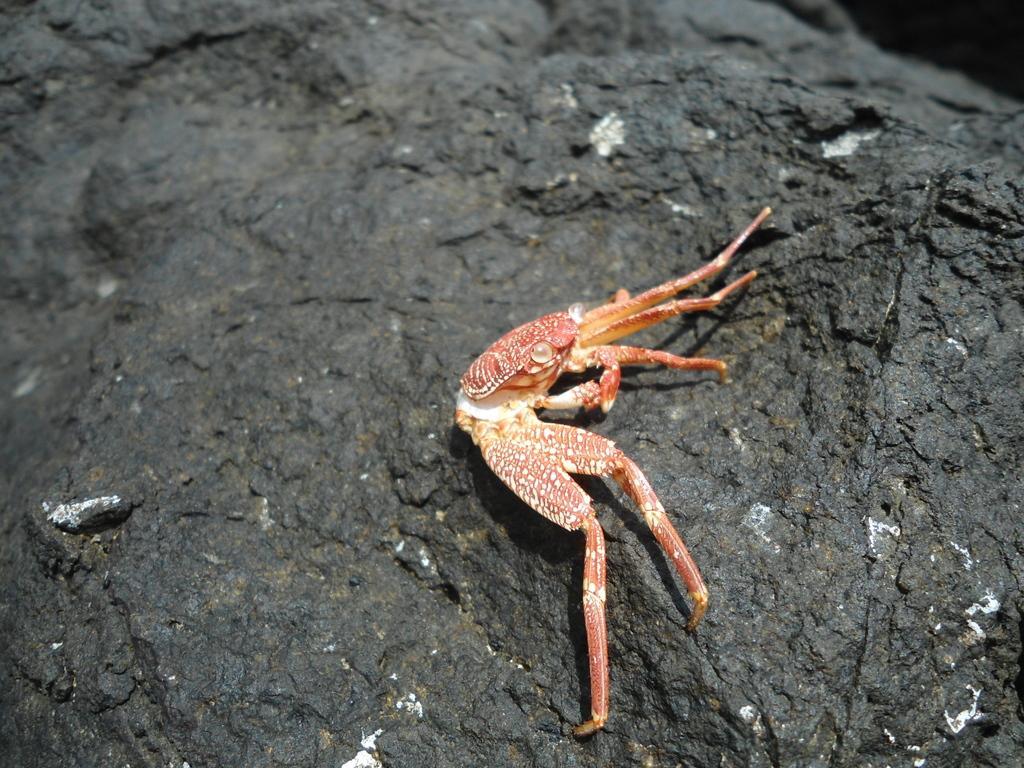Please provide a concise description of this image. In this picture, we can see a crab on the surface. 